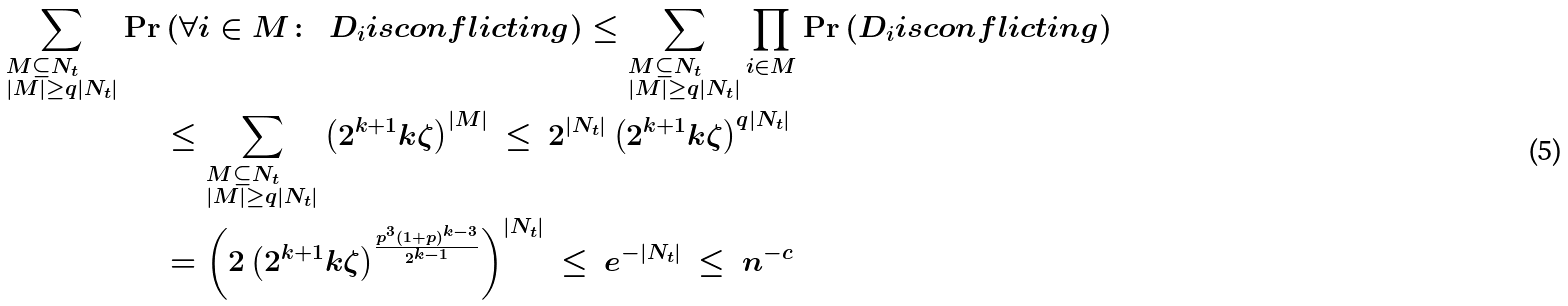<formula> <loc_0><loc_0><loc_500><loc_500>\sum _ { \begin{subarray} 1 M \subseteq N _ { t } \\ | M | \geq q | N _ { t } | \end{subarray} } \Pr & \left ( \forall i \in M \colon \ \ D _ { i } i s c o n f l i c t i n g \right ) \leq \sum _ { \begin{subarray} 1 M \subseteq N _ { t } \\ | M | \geq q | N _ { t } | \end{subarray} } \prod _ { i \in M } \Pr \left ( D _ { i } i s c o n f l i c t i n g \right ) \\ & \leq \sum _ { \begin{subarray} 1 M \subseteq N _ { t } \\ | M | \geq q | N _ { t } | \end{subarray} } \left ( 2 ^ { k + 1 } k \zeta \right ) ^ { | M | } \ \leq \ 2 ^ { | N _ { t } | } \left ( 2 ^ { k + 1 } k \zeta \right ) ^ { q | N _ { t } | } \\ & = \left ( 2 \left ( 2 ^ { k + 1 } k \zeta \right ) ^ { \frac { p ^ { 3 } ( 1 + p ) ^ { k - 3 } } { 2 ^ { k - 1 } } } \right ) ^ { | N _ { t } | } \ \leq \ e ^ { - | N _ { t } | } \ \leq \ n ^ { - c }</formula> 